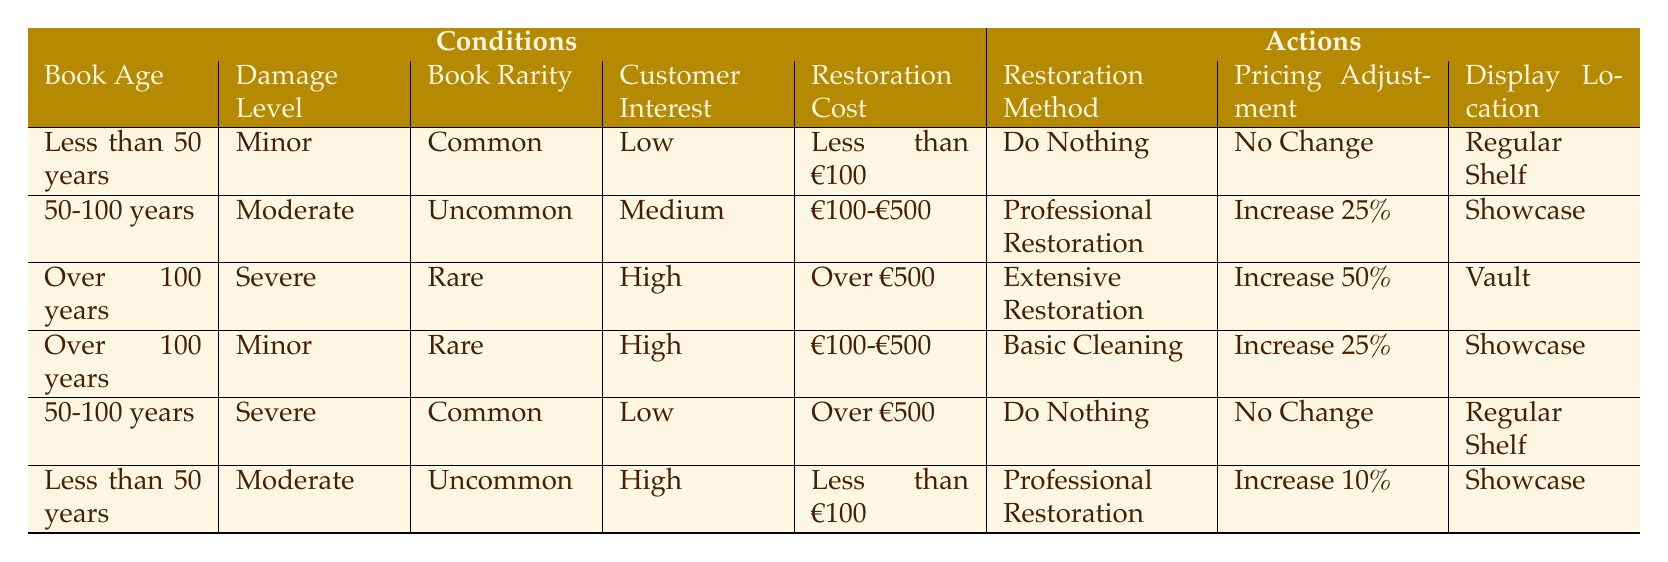What restoration method should be used for a book that is over 100 years old, severely damaged, rare, and has a restoration cost of over €500? According to the table, if a book is over 100 years old, has severe damage, is rare, and has a restoration cost of over €500, the appropriate restoration method is "Extensive Restoration." This is directly seen in the rule regarding that specific condition.
Answer: Extensive Restoration If a book is under 50 years old and has minor damage, what action should be taken regarding pricing? The table indicates that for a book less than 50 years old with minor damage, the pricing adjustment should be "No Change." This matches the specified conditions directly in the table.
Answer: No Change Is it true that moderate damage on a book between 50 to 100 years old should be handled with professional restoration? Yes, this statement is true. The table shows that for a book that is 50 to 100 years old with moderate damage, the recommended restoration method is indeed "Professional Restoration."
Answer: Yes What is the display location for a book that is less than 50 years old, has moderate damage, is uncommon, has high customer interest, and costs less than €100? For this specific set of conditions, the table indicates that the action is to use "Showcase" as the display location. Each condition matches one defined in the table.
Answer: Showcase What is the total number of actions that involve "Do Nothing"? The table presents a total of two actions that involve "Do Nothing." The first is for a book less than 50 years old with minor damage and common rarity, and the second is for a book between 50 to 100 years old with severe damage and common rarity, specifically under the provided cost criteria.
Answer: 2 What restoration strategies are recommended for a rare book that is over 100 years old, has minor damage, and costs between €100 and €500? In this scenario, the table states that the recommended restoration strategy is "Basic Cleaning." This aligns with the specific conditions for that restoration method as outlined in the rules.
Answer: Basic Cleaning For a book that is 50 to 100 years old, how much should the price increase if it has moderate damage and is uncommon with medium customer interest? The table specifies that for a book in this range with moderate damage, the price should be increased by 25 percent. Those conditions precisely outline the action taken according to the rules in the table.
Answer: Increase 25% How many total rows pertain to books rated as "Rare"? There are three rows in the table associated with books rated as "Rare." This is determined by counting each rule that includes the rarity classification of "Rare."
Answer: 3 